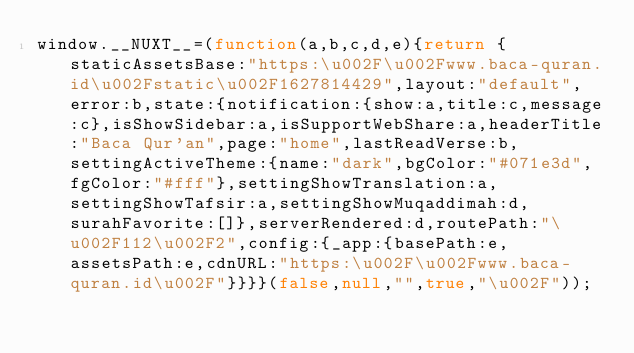<code> <loc_0><loc_0><loc_500><loc_500><_JavaScript_>window.__NUXT__=(function(a,b,c,d,e){return {staticAssetsBase:"https:\u002F\u002Fwww.baca-quran.id\u002Fstatic\u002F1627814429",layout:"default",error:b,state:{notification:{show:a,title:c,message:c},isShowSidebar:a,isSupportWebShare:a,headerTitle:"Baca Qur'an",page:"home",lastReadVerse:b,settingActiveTheme:{name:"dark",bgColor:"#071e3d",fgColor:"#fff"},settingShowTranslation:a,settingShowTafsir:a,settingShowMuqaddimah:d,surahFavorite:[]},serverRendered:d,routePath:"\u002F112\u002F2",config:{_app:{basePath:e,assetsPath:e,cdnURL:"https:\u002F\u002Fwww.baca-quran.id\u002F"}}}}(false,null,"",true,"\u002F"));</code> 